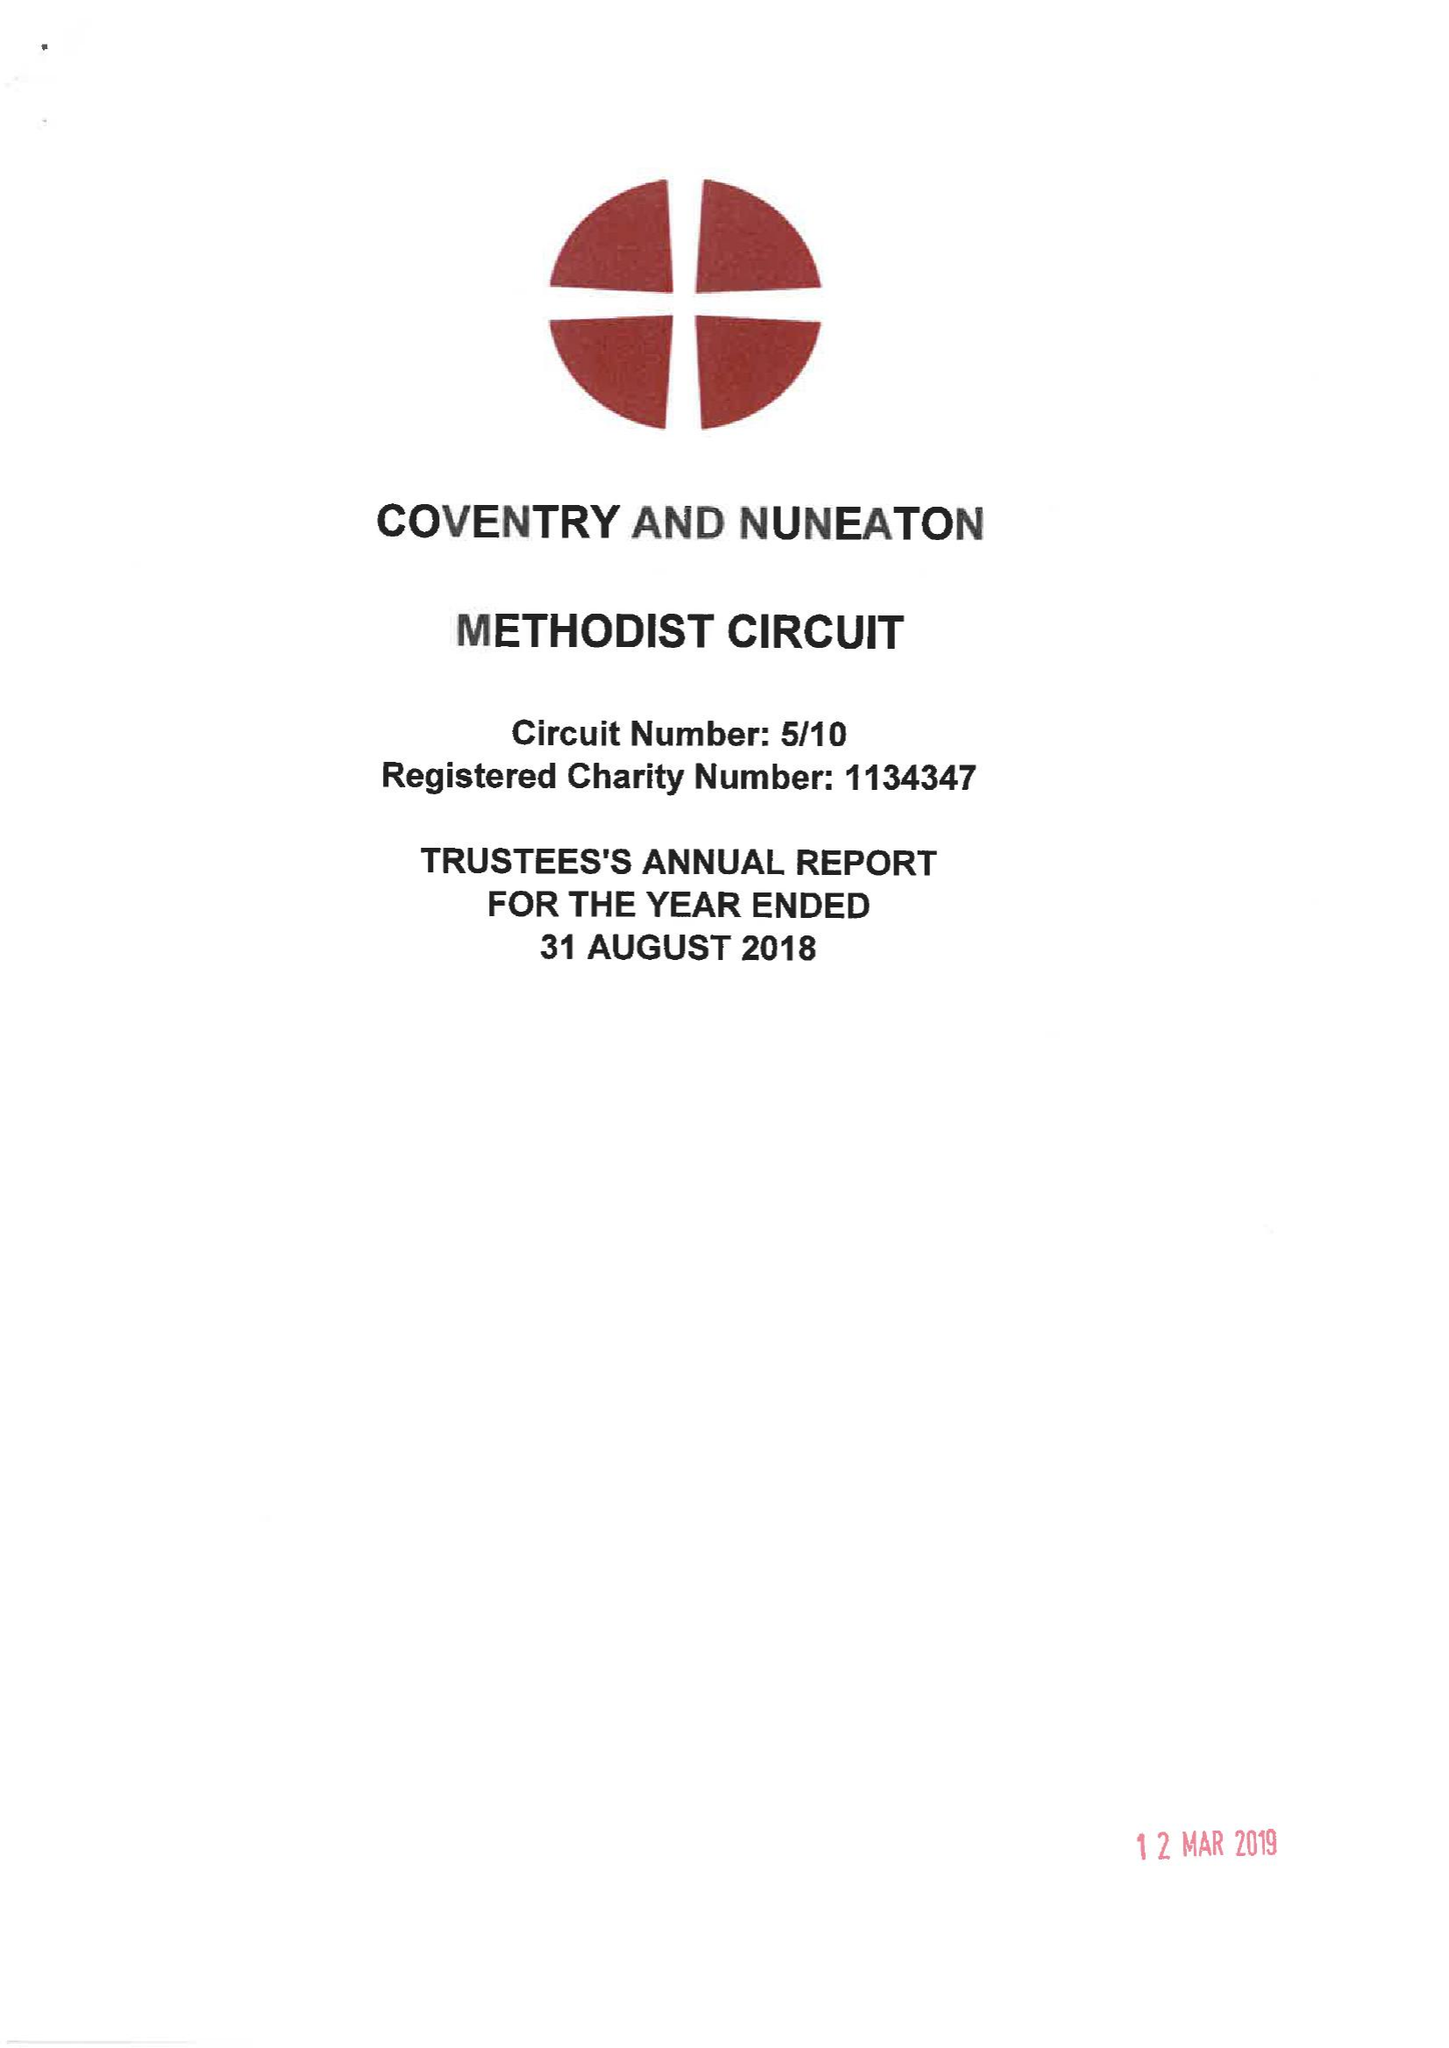What is the value for the address__postcode?
Answer the question using a single word or phrase. CV1 2HA 